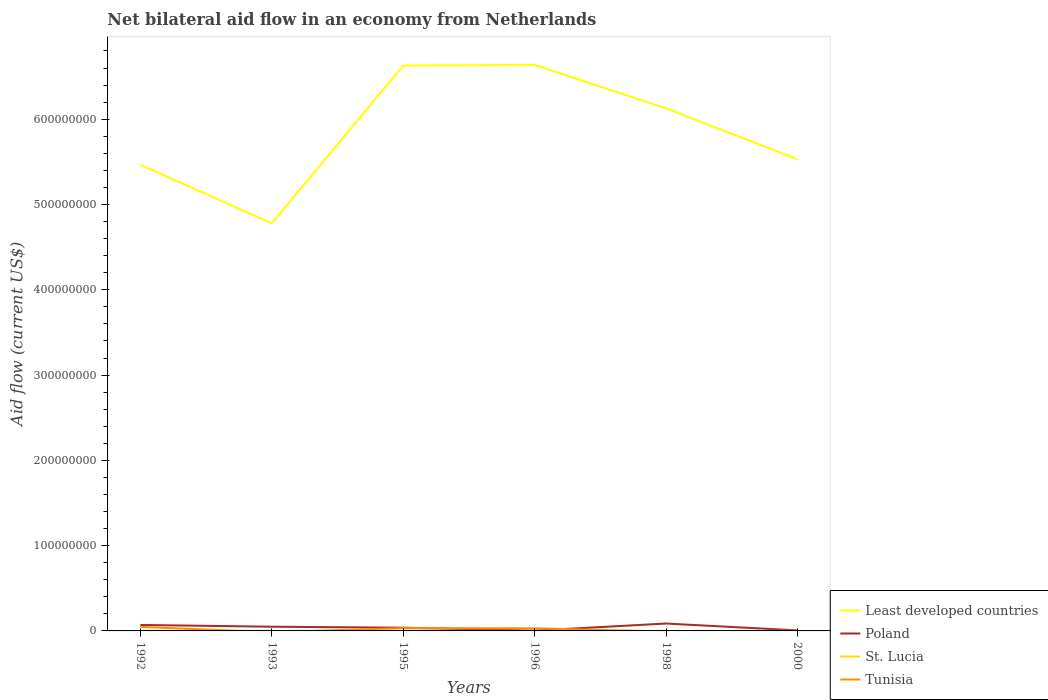How many different coloured lines are there?
Your answer should be very brief. 4. What is the total net bilateral aid flow in Tunisia in the graph?
Provide a short and direct response. 1.49e+06. What is the difference between the highest and the second highest net bilateral aid flow in Least developed countries?
Offer a very short reply. 1.86e+08. Is the net bilateral aid flow in Tunisia strictly greater than the net bilateral aid flow in Least developed countries over the years?
Your response must be concise. Yes. How many lines are there?
Offer a terse response. 4. How many years are there in the graph?
Provide a succinct answer. 6. What is the difference between two consecutive major ticks on the Y-axis?
Your answer should be compact. 1.00e+08. Does the graph contain any zero values?
Keep it short and to the point. Yes. How many legend labels are there?
Make the answer very short. 4. How are the legend labels stacked?
Your answer should be very brief. Vertical. What is the title of the graph?
Offer a very short reply. Net bilateral aid flow in an economy from Netherlands. Does "Madagascar" appear as one of the legend labels in the graph?
Your answer should be very brief. No. What is the label or title of the X-axis?
Provide a succinct answer. Years. What is the label or title of the Y-axis?
Make the answer very short. Aid flow (current US$). What is the Aid flow (current US$) of Least developed countries in 1992?
Keep it short and to the point. 5.47e+08. What is the Aid flow (current US$) of Poland in 1992?
Ensure brevity in your answer.  7.00e+06. What is the Aid flow (current US$) of St. Lucia in 1992?
Your answer should be compact. 1.80e+05. What is the Aid flow (current US$) of Tunisia in 1992?
Offer a terse response. 4.77e+06. What is the Aid flow (current US$) in Least developed countries in 1993?
Provide a succinct answer. 4.78e+08. What is the Aid flow (current US$) in Poland in 1993?
Provide a short and direct response. 4.94e+06. What is the Aid flow (current US$) in St. Lucia in 1993?
Your answer should be very brief. 1.30e+05. What is the Aid flow (current US$) of Least developed countries in 1995?
Keep it short and to the point. 6.63e+08. What is the Aid flow (current US$) in Poland in 1995?
Give a very brief answer. 3.75e+06. What is the Aid flow (current US$) in St. Lucia in 1995?
Keep it short and to the point. 1.90e+05. What is the Aid flow (current US$) in Tunisia in 1995?
Keep it short and to the point. 3.28e+06. What is the Aid flow (current US$) of Least developed countries in 1996?
Your answer should be very brief. 6.64e+08. What is the Aid flow (current US$) of Poland in 1996?
Ensure brevity in your answer.  3.60e+05. What is the Aid flow (current US$) in Tunisia in 1996?
Your response must be concise. 3.08e+06. What is the Aid flow (current US$) of Least developed countries in 1998?
Offer a terse response. 6.13e+08. What is the Aid flow (current US$) of Poland in 1998?
Ensure brevity in your answer.  8.66e+06. What is the Aid flow (current US$) in St. Lucia in 1998?
Keep it short and to the point. 1.10e+05. What is the Aid flow (current US$) in Tunisia in 1998?
Provide a short and direct response. 0. What is the Aid flow (current US$) in Least developed countries in 2000?
Your response must be concise. 5.53e+08. What is the Aid flow (current US$) of Poland in 2000?
Provide a short and direct response. 5.80e+05. What is the Aid flow (current US$) in St. Lucia in 2000?
Provide a succinct answer. 2.00e+04. Across all years, what is the maximum Aid flow (current US$) of Least developed countries?
Provide a short and direct response. 6.64e+08. Across all years, what is the maximum Aid flow (current US$) of Poland?
Your response must be concise. 8.66e+06. Across all years, what is the maximum Aid flow (current US$) in St. Lucia?
Your answer should be very brief. 1.90e+05. Across all years, what is the maximum Aid flow (current US$) of Tunisia?
Your answer should be very brief. 4.77e+06. Across all years, what is the minimum Aid flow (current US$) in Least developed countries?
Offer a very short reply. 4.78e+08. Across all years, what is the minimum Aid flow (current US$) of Poland?
Offer a terse response. 3.60e+05. Across all years, what is the minimum Aid flow (current US$) of St. Lucia?
Make the answer very short. 2.00e+04. Across all years, what is the minimum Aid flow (current US$) of Tunisia?
Offer a terse response. 0. What is the total Aid flow (current US$) in Least developed countries in the graph?
Ensure brevity in your answer.  3.52e+09. What is the total Aid flow (current US$) in Poland in the graph?
Give a very brief answer. 2.53e+07. What is the total Aid flow (current US$) in St. Lucia in the graph?
Your answer should be very brief. 7.20e+05. What is the total Aid flow (current US$) in Tunisia in the graph?
Offer a terse response. 1.11e+07. What is the difference between the Aid flow (current US$) of Least developed countries in 1992 and that in 1993?
Provide a succinct answer. 6.87e+07. What is the difference between the Aid flow (current US$) in Poland in 1992 and that in 1993?
Keep it short and to the point. 2.06e+06. What is the difference between the Aid flow (current US$) in Least developed countries in 1992 and that in 1995?
Ensure brevity in your answer.  -1.16e+08. What is the difference between the Aid flow (current US$) in Poland in 1992 and that in 1995?
Keep it short and to the point. 3.25e+06. What is the difference between the Aid flow (current US$) of Tunisia in 1992 and that in 1995?
Provide a succinct answer. 1.49e+06. What is the difference between the Aid flow (current US$) of Least developed countries in 1992 and that in 1996?
Offer a very short reply. -1.17e+08. What is the difference between the Aid flow (current US$) in Poland in 1992 and that in 1996?
Provide a short and direct response. 6.64e+06. What is the difference between the Aid flow (current US$) in Tunisia in 1992 and that in 1996?
Keep it short and to the point. 1.69e+06. What is the difference between the Aid flow (current US$) in Least developed countries in 1992 and that in 1998?
Offer a very short reply. -6.61e+07. What is the difference between the Aid flow (current US$) in Poland in 1992 and that in 1998?
Your answer should be compact. -1.66e+06. What is the difference between the Aid flow (current US$) of Least developed countries in 1992 and that in 2000?
Ensure brevity in your answer.  -6.55e+06. What is the difference between the Aid flow (current US$) of Poland in 1992 and that in 2000?
Keep it short and to the point. 6.42e+06. What is the difference between the Aid flow (current US$) in St. Lucia in 1992 and that in 2000?
Ensure brevity in your answer.  1.60e+05. What is the difference between the Aid flow (current US$) in Least developed countries in 1993 and that in 1995?
Provide a succinct answer. -1.85e+08. What is the difference between the Aid flow (current US$) of Poland in 1993 and that in 1995?
Keep it short and to the point. 1.19e+06. What is the difference between the Aid flow (current US$) in Least developed countries in 1993 and that in 1996?
Give a very brief answer. -1.86e+08. What is the difference between the Aid flow (current US$) in Poland in 1993 and that in 1996?
Your answer should be very brief. 4.58e+06. What is the difference between the Aid flow (current US$) in St. Lucia in 1993 and that in 1996?
Your response must be concise. 4.00e+04. What is the difference between the Aid flow (current US$) in Least developed countries in 1993 and that in 1998?
Provide a short and direct response. -1.35e+08. What is the difference between the Aid flow (current US$) of Poland in 1993 and that in 1998?
Provide a succinct answer. -3.72e+06. What is the difference between the Aid flow (current US$) of St. Lucia in 1993 and that in 1998?
Provide a succinct answer. 2.00e+04. What is the difference between the Aid flow (current US$) of Least developed countries in 1993 and that in 2000?
Offer a terse response. -7.52e+07. What is the difference between the Aid flow (current US$) in Poland in 1993 and that in 2000?
Offer a terse response. 4.36e+06. What is the difference between the Aid flow (current US$) in St. Lucia in 1993 and that in 2000?
Keep it short and to the point. 1.10e+05. What is the difference between the Aid flow (current US$) in Least developed countries in 1995 and that in 1996?
Provide a short and direct response. -7.40e+05. What is the difference between the Aid flow (current US$) in Poland in 1995 and that in 1996?
Give a very brief answer. 3.39e+06. What is the difference between the Aid flow (current US$) of Least developed countries in 1995 and that in 1998?
Ensure brevity in your answer.  5.02e+07. What is the difference between the Aid flow (current US$) in Poland in 1995 and that in 1998?
Ensure brevity in your answer.  -4.91e+06. What is the difference between the Aid flow (current US$) of Least developed countries in 1995 and that in 2000?
Provide a short and direct response. 1.10e+08. What is the difference between the Aid flow (current US$) of Poland in 1995 and that in 2000?
Your response must be concise. 3.17e+06. What is the difference between the Aid flow (current US$) in Least developed countries in 1996 and that in 1998?
Offer a very short reply. 5.10e+07. What is the difference between the Aid flow (current US$) of Poland in 1996 and that in 1998?
Offer a very short reply. -8.30e+06. What is the difference between the Aid flow (current US$) of St. Lucia in 1996 and that in 1998?
Offer a very short reply. -2.00e+04. What is the difference between the Aid flow (current US$) in Least developed countries in 1996 and that in 2000?
Ensure brevity in your answer.  1.10e+08. What is the difference between the Aid flow (current US$) of Poland in 1996 and that in 2000?
Ensure brevity in your answer.  -2.20e+05. What is the difference between the Aid flow (current US$) of St. Lucia in 1996 and that in 2000?
Make the answer very short. 7.00e+04. What is the difference between the Aid flow (current US$) in Least developed countries in 1998 and that in 2000?
Your answer should be compact. 5.95e+07. What is the difference between the Aid flow (current US$) in Poland in 1998 and that in 2000?
Make the answer very short. 8.08e+06. What is the difference between the Aid flow (current US$) in Least developed countries in 1992 and the Aid flow (current US$) in Poland in 1993?
Your response must be concise. 5.42e+08. What is the difference between the Aid flow (current US$) of Least developed countries in 1992 and the Aid flow (current US$) of St. Lucia in 1993?
Provide a succinct answer. 5.46e+08. What is the difference between the Aid flow (current US$) in Poland in 1992 and the Aid flow (current US$) in St. Lucia in 1993?
Your response must be concise. 6.87e+06. What is the difference between the Aid flow (current US$) of Least developed countries in 1992 and the Aid flow (current US$) of Poland in 1995?
Provide a short and direct response. 5.43e+08. What is the difference between the Aid flow (current US$) in Least developed countries in 1992 and the Aid flow (current US$) in St. Lucia in 1995?
Give a very brief answer. 5.46e+08. What is the difference between the Aid flow (current US$) in Least developed countries in 1992 and the Aid flow (current US$) in Tunisia in 1995?
Offer a terse response. 5.43e+08. What is the difference between the Aid flow (current US$) in Poland in 1992 and the Aid flow (current US$) in St. Lucia in 1995?
Give a very brief answer. 6.81e+06. What is the difference between the Aid flow (current US$) in Poland in 1992 and the Aid flow (current US$) in Tunisia in 1995?
Keep it short and to the point. 3.72e+06. What is the difference between the Aid flow (current US$) of St. Lucia in 1992 and the Aid flow (current US$) of Tunisia in 1995?
Offer a very short reply. -3.10e+06. What is the difference between the Aid flow (current US$) in Least developed countries in 1992 and the Aid flow (current US$) in Poland in 1996?
Provide a succinct answer. 5.46e+08. What is the difference between the Aid flow (current US$) of Least developed countries in 1992 and the Aid flow (current US$) of St. Lucia in 1996?
Offer a very short reply. 5.46e+08. What is the difference between the Aid flow (current US$) of Least developed countries in 1992 and the Aid flow (current US$) of Tunisia in 1996?
Give a very brief answer. 5.44e+08. What is the difference between the Aid flow (current US$) in Poland in 1992 and the Aid flow (current US$) in St. Lucia in 1996?
Give a very brief answer. 6.91e+06. What is the difference between the Aid flow (current US$) of Poland in 1992 and the Aid flow (current US$) of Tunisia in 1996?
Your answer should be very brief. 3.92e+06. What is the difference between the Aid flow (current US$) in St. Lucia in 1992 and the Aid flow (current US$) in Tunisia in 1996?
Offer a terse response. -2.90e+06. What is the difference between the Aid flow (current US$) of Least developed countries in 1992 and the Aid flow (current US$) of Poland in 1998?
Keep it short and to the point. 5.38e+08. What is the difference between the Aid flow (current US$) in Least developed countries in 1992 and the Aid flow (current US$) in St. Lucia in 1998?
Give a very brief answer. 5.46e+08. What is the difference between the Aid flow (current US$) of Poland in 1992 and the Aid flow (current US$) of St. Lucia in 1998?
Offer a very short reply. 6.89e+06. What is the difference between the Aid flow (current US$) in Least developed countries in 1992 and the Aid flow (current US$) in Poland in 2000?
Your answer should be compact. 5.46e+08. What is the difference between the Aid flow (current US$) in Least developed countries in 1992 and the Aid flow (current US$) in St. Lucia in 2000?
Offer a very short reply. 5.47e+08. What is the difference between the Aid flow (current US$) of Poland in 1992 and the Aid flow (current US$) of St. Lucia in 2000?
Offer a terse response. 6.98e+06. What is the difference between the Aid flow (current US$) in Least developed countries in 1993 and the Aid flow (current US$) in Poland in 1995?
Keep it short and to the point. 4.74e+08. What is the difference between the Aid flow (current US$) of Least developed countries in 1993 and the Aid flow (current US$) of St. Lucia in 1995?
Your answer should be compact. 4.78e+08. What is the difference between the Aid flow (current US$) of Least developed countries in 1993 and the Aid flow (current US$) of Tunisia in 1995?
Ensure brevity in your answer.  4.75e+08. What is the difference between the Aid flow (current US$) in Poland in 1993 and the Aid flow (current US$) in St. Lucia in 1995?
Keep it short and to the point. 4.75e+06. What is the difference between the Aid flow (current US$) of Poland in 1993 and the Aid flow (current US$) of Tunisia in 1995?
Offer a very short reply. 1.66e+06. What is the difference between the Aid flow (current US$) of St. Lucia in 1993 and the Aid flow (current US$) of Tunisia in 1995?
Your response must be concise. -3.15e+06. What is the difference between the Aid flow (current US$) in Least developed countries in 1993 and the Aid flow (current US$) in Poland in 1996?
Your answer should be compact. 4.78e+08. What is the difference between the Aid flow (current US$) in Least developed countries in 1993 and the Aid flow (current US$) in St. Lucia in 1996?
Provide a succinct answer. 4.78e+08. What is the difference between the Aid flow (current US$) in Least developed countries in 1993 and the Aid flow (current US$) in Tunisia in 1996?
Provide a succinct answer. 4.75e+08. What is the difference between the Aid flow (current US$) in Poland in 1993 and the Aid flow (current US$) in St. Lucia in 1996?
Provide a succinct answer. 4.85e+06. What is the difference between the Aid flow (current US$) in Poland in 1993 and the Aid flow (current US$) in Tunisia in 1996?
Ensure brevity in your answer.  1.86e+06. What is the difference between the Aid flow (current US$) of St. Lucia in 1993 and the Aid flow (current US$) of Tunisia in 1996?
Give a very brief answer. -2.95e+06. What is the difference between the Aid flow (current US$) of Least developed countries in 1993 and the Aid flow (current US$) of Poland in 1998?
Your answer should be very brief. 4.69e+08. What is the difference between the Aid flow (current US$) in Least developed countries in 1993 and the Aid flow (current US$) in St. Lucia in 1998?
Your answer should be compact. 4.78e+08. What is the difference between the Aid flow (current US$) in Poland in 1993 and the Aid flow (current US$) in St. Lucia in 1998?
Ensure brevity in your answer.  4.83e+06. What is the difference between the Aid flow (current US$) in Least developed countries in 1993 and the Aid flow (current US$) in Poland in 2000?
Offer a terse response. 4.77e+08. What is the difference between the Aid flow (current US$) of Least developed countries in 1993 and the Aid flow (current US$) of St. Lucia in 2000?
Give a very brief answer. 4.78e+08. What is the difference between the Aid flow (current US$) of Poland in 1993 and the Aid flow (current US$) of St. Lucia in 2000?
Make the answer very short. 4.92e+06. What is the difference between the Aid flow (current US$) of Least developed countries in 1995 and the Aid flow (current US$) of Poland in 1996?
Offer a terse response. 6.63e+08. What is the difference between the Aid flow (current US$) in Least developed countries in 1995 and the Aid flow (current US$) in St. Lucia in 1996?
Your answer should be very brief. 6.63e+08. What is the difference between the Aid flow (current US$) in Least developed countries in 1995 and the Aid flow (current US$) in Tunisia in 1996?
Offer a very short reply. 6.60e+08. What is the difference between the Aid flow (current US$) of Poland in 1995 and the Aid flow (current US$) of St. Lucia in 1996?
Provide a short and direct response. 3.66e+06. What is the difference between the Aid flow (current US$) of Poland in 1995 and the Aid flow (current US$) of Tunisia in 1996?
Provide a short and direct response. 6.70e+05. What is the difference between the Aid flow (current US$) of St. Lucia in 1995 and the Aid flow (current US$) of Tunisia in 1996?
Your answer should be compact. -2.89e+06. What is the difference between the Aid flow (current US$) in Least developed countries in 1995 and the Aid flow (current US$) in Poland in 1998?
Make the answer very short. 6.54e+08. What is the difference between the Aid flow (current US$) in Least developed countries in 1995 and the Aid flow (current US$) in St. Lucia in 1998?
Give a very brief answer. 6.63e+08. What is the difference between the Aid flow (current US$) in Poland in 1995 and the Aid flow (current US$) in St. Lucia in 1998?
Provide a short and direct response. 3.64e+06. What is the difference between the Aid flow (current US$) of Least developed countries in 1995 and the Aid flow (current US$) of Poland in 2000?
Ensure brevity in your answer.  6.62e+08. What is the difference between the Aid flow (current US$) in Least developed countries in 1995 and the Aid flow (current US$) in St. Lucia in 2000?
Ensure brevity in your answer.  6.63e+08. What is the difference between the Aid flow (current US$) of Poland in 1995 and the Aid flow (current US$) of St. Lucia in 2000?
Your answer should be very brief. 3.73e+06. What is the difference between the Aid flow (current US$) in Least developed countries in 1996 and the Aid flow (current US$) in Poland in 1998?
Offer a terse response. 6.55e+08. What is the difference between the Aid flow (current US$) in Least developed countries in 1996 and the Aid flow (current US$) in St. Lucia in 1998?
Your answer should be very brief. 6.64e+08. What is the difference between the Aid flow (current US$) in Poland in 1996 and the Aid flow (current US$) in St. Lucia in 1998?
Ensure brevity in your answer.  2.50e+05. What is the difference between the Aid flow (current US$) in Least developed countries in 1996 and the Aid flow (current US$) in Poland in 2000?
Your response must be concise. 6.63e+08. What is the difference between the Aid flow (current US$) of Least developed countries in 1996 and the Aid flow (current US$) of St. Lucia in 2000?
Provide a short and direct response. 6.64e+08. What is the difference between the Aid flow (current US$) in Least developed countries in 1998 and the Aid flow (current US$) in Poland in 2000?
Provide a succinct answer. 6.12e+08. What is the difference between the Aid flow (current US$) in Least developed countries in 1998 and the Aid flow (current US$) in St. Lucia in 2000?
Your answer should be compact. 6.13e+08. What is the difference between the Aid flow (current US$) of Poland in 1998 and the Aid flow (current US$) of St. Lucia in 2000?
Offer a terse response. 8.64e+06. What is the average Aid flow (current US$) in Least developed countries per year?
Ensure brevity in your answer.  5.86e+08. What is the average Aid flow (current US$) in Poland per year?
Give a very brief answer. 4.22e+06. What is the average Aid flow (current US$) of St. Lucia per year?
Provide a short and direct response. 1.20e+05. What is the average Aid flow (current US$) in Tunisia per year?
Give a very brief answer. 1.86e+06. In the year 1992, what is the difference between the Aid flow (current US$) in Least developed countries and Aid flow (current US$) in Poland?
Give a very brief answer. 5.40e+08. In the year 1992, what is the difference between the Aid flow (current US$) of Least developed countries and Aid flow (current US$) of St. Lucia?
Ensure brevity in your answer.  5.46e+08. In the year 1992, what is the difference between the Aid flow (current US$) in Least developed countries and Aid flow (current US$) in Tunisia?
Offer a terse response. 5.42e+08. In the year 1992, what is the difference between the Aid flow (current US$) of Poland and Aid flow (current US$) of St. Lucia?
Your answer should be compact. 6.82e+06. In the year 1992, what is the difference between the Aid flow (current US$) in Poland and Aid flow (current US$) in Tunisia?
Offer a very short reply. 2.23e+06. In the year 1992, what is the difference between the Aid flow (current US$) of St. Lucia and Aid flow (current US$) of Tunisia?
Offer a very short reply. -4.59e+06. In the year 1993, what is the difference between the Aid flow (current US$) of Least developed countries and Aid flow (current US$) of Poland?
Your answer should be compact. 4.73e+08. In the year 1993, what is the difference between the Aid flow (current US$) of Least developed countries and Aid flow (current US$) of St. Lucia?
Offer a very short reply. 4.78e+08. In the year 1993, what is the difference between the Aid flow (current US$) of Poland and Aid flow (current US$) of St. Lucia?
Your answer should be very brief. 4.81e+06. In the year 1995, what is the difference between the Aid flow (current US$) in Least developed countries and Aid flow (current US$) in Poland?
Give a very brief answer. 6.59e+08. In the year 1995, what is the difference between the Aid flow (current US$) of Least developed countries and Aid flow (current US$) of St. Lucia?
Ensure brevity in your answer.  6.63e+08. In the year 1995, what is the difference between the Aid flow (current US$) of Least developed countries and Aid flow (current US$) of Tunisia?
Provide a succinct answer. 6.60e+08. In the year 1995, what is the difference between the Aid flow (current US$) of Poland and Aid flow (current US$) of St. Lucia?
Provide a succinct answer. 3.56e+06. In the year 1995, what is the difference between the Aid flow (current US$) of Poland and Aid flow (current US$) of Tunisia?
Make the answer very short. 4.70e+05. In the year 1995, what is the difference between the Aid flow (current US$) in St. Lucia and Aid flow (current US$) in Tunisia?
Provide a succinct answer. -3.09e+06. In the year 1996, what is the difference between the Aid flow (current US$) of Least developed countries and Aid flow (current US$) of Poland?
Give a very brief answer. 6.63e+08. In the year 1996, what is the difference between the Aid flow (current US$) of Least developed countries and Aid flow (current US$) of St. Lucia?
Ensure brevity in your answer.  6.64e+08. In the year 1996, what is the difference between the Aid flow (current US$) of Least developed countries and Aid flow (current US$) of Tunisia?
Your response must be concise. 6.61e+08. In the year 1996, what is the difference between the Aid flow (current US$) in Poland and Aid flow (current US$) in Tunisia?
Keep it short and to the point. -2.72e+06. In the year 1996, what is the difference between the Aid flow (current US$) of St. Lucia and Aid flow (current US$) of Tunisia?
Offer a terse response. -2.99e+06. In the year 1998, what is the difference between the Aid flow (current US$) of Least developed countries and Aid flow (current US$) of Poland?
Your answer should be compact. 6.04e+08. In the year 1998, what is the difference between the Aid flow (current US$) in Least developed countries and Aid flow (current US$) in St. Lucia?
Offer a terse response. 6.13e+08. In the year 1998, what is the difference between the Aid flow (current US$) of Poland and Aid flow (current US$) of St. Lucia?
Ensure brevity in your answer.  8.55e+06. In the year 2000, what is the difference between the Aid flow (current US$) in Least developed countries and Aid flow (current US$) in Poland?
Provide a short and direct response. 5.53e+08. In the year 2000, what is the difference between the Aid flow (current US$) in Least developed countries and Aid flow (current US$) in St. Lucia?
Make the answer very short. 5.53e+08. In the year 2000, what is the difference between the Aid flow (current US$) of Poland and Aid flow (current US$) of St. Lucia?
Your answer should be compact. 5.60e+05. What is the ratio of the Aid flow (current US$) in Least developed countries in 1992 to that in 1993?
Offer a very short reply. 1.14. What is the ratio of the Aid flow (current US$) in Poland in 1992 to that in 1993?
Your answer should be very brief. 1.42. What is the ratio of the Aid flow (current US$) of St. Lucia in 1992 to that in 1993?
Your answer should be very brief. 1.38. What is the ratio of the Aid flow (current US$) in Least developed countries in 1992 to that in 1995?
Provide a short and direct response. 0.82. What is the ratio of the Aid flow (current US$) of Poland in 1992 to that in 1995?
Keep it short and to the point. 1.87. What is the ratio of the Aid flow (current US$) in St. Lucia in 1992 to that in 1995?
Your response must be concise. 0.95. What is the ratio of the Aid flow (current US$) of Tunisia in 1992 to that in 1995?
Your answer should be compact. 1.45. What is the ratio of the Aid flow (current US$) of Least developed countries in 1992 to that in 1996?
Provide a succinct answer. 0.82. What is the ratio of the Aid flow (current US$) of Poland in 1992 to that in 1996?
Your answer should be compact. 19.44. What is the ratio of the Aid flow (current US$) of St. Lucia in 1992 to that in 1996?
Make the answer very short. 2. What is the ratio of the Aid flow (current US$) of Tunisia in 1992 to that in 1996?
Provide a succinct answer. 1.55. What is the ratio of the Aid flow (current US$) in Least developed countries in 1992 to that in 1998?
Give a very brief answer. 0.89. What is the ratio of the Aid flow (current US$) in Poland in 1992 to that in 1998?
Give a very brief answer. 0.81. What is the ratio of the Aid flow (current US$) of St. Lucia in 1992 to that in 1998?
Provide a succinct answer. 1.64. What is the ratio of the Aid flow (current US$) of Poland in 1992 to that in 2000?
Your answer should be compact. 12.07. What is the ratio of the Aid flow (current US$) of Least developed countries in 1993 to that in 1995?
Offer a terse response. 0.72. What is the ratio of the Aid flow (current US$) in Poland in 1993 to that in 1995?
Provide a short and direct response. 1.32. What is the ratio of the Aid flow (current US$) of St. Lucia in 1993 to that in 1995?
Give a very brief answer. 0.68. What is the ratio of the Aid flow (current US$) of Least developed countries in 1993 to that in 1996?
Provide a short and direct response. 0.72. What is the ratio of the Aid flow (current US$) of Poland in 1993 to that in 1996?
Your answer should be compact. 13.72. What is the ratio of the Aid flow (current US$) in St. Lucia in 1993 to that in 1996?
Your answer should be very brief. 1.44. What is the ratio of the Aid flow (current US$) in Least developed countries in 1993 to that in 1998?
Make the answer very short. 0.78. What is the ratio of the Aid flow (current US$) of Poland in 1993 to that in 1998?
Offer a terse response. 0.57. What is the ratio of the Aid flow (current US$) of St. Lucia in 1993 to that in 1998?
Your response must be concise. 1.18. What is the ratio of the Aid flow (current US$) of Least developed countries in 1993 to that in 2000?
Provide a succinct answer. 0.86. What is the ratio of the Aid flow (current US$) of Poland in 1993 to that in 2000?
Ensure brevity in your answer.  8.52. What is the ratio of the Aid flow (current US$) of St. Lucia in 1993 to that in 2000?
Provide a short and direct response. 6.5. What is the ratio of the Aid flow (current US$) in Poland in 1995 to that in 1996?
Keep it short and to the point. 10.42. What is the ratio of the Aid flow (current US$) of St. Lucia in 1995 to that in 1996?
Your response must be concise. 2.11. What is the ratio of the Aid flow (current US$) of Tunisia in 1995 to that in 1996?
Provide a succinct answer. 1.06. What is the ratio of the Aid flow (current US$) in Least developed countries in 1995 to that in 1998?
Your response must be concise. 1.08. What is the ratio of the Aid flow (current US$) in Poland in 1995 to that in 1998?
Offer a very short reply. 0.43. What is the ratio of the Aid flow (current US$) of St. Lucia in 1995 to that in 1998?
Provide a short and direct response. 1.73. What is the ratio of the Aid flow (current US$) of Least developed countries in 1995 to that in 2000?
Offer a very short reply. 1.2. What is the ratio of the Aid flow (current US$) of Poland in 1995 to that in 2000?
Offer a very short reply. 6.47. What is the ratio of the Aid flow (current US$) of St. Lucia in 1995 to that in 2000?
Provide a succinct answer. 9.5. What is the ratio of the Aid flow (current US$) in Least developed countries in 1996 to that in 1998?
Make the answer very short. 1.08. What is the ratio of the Aid flow (current US$) in Poland in 1996 to that in 1998?
Give a very brief answer. 0.04. What is the ratio of the Aid flow (current US$) of St. Lucia in 1996 to that in 1998?
Offer a terse response. 0.82. What is the ratio of the Aid flow (current US$) of Least developed countries in 1996 to that in 2000?
Offer a terse response. 1.2. What is the ratio of the Aid flow (current US$) of Poland in 1996 to that in 2000?
Ensure brevity in your answer.  0.62. What is the ratio of the Aid flow (current US$) of Least developed countries in 1998 to that in 2000?
Keep it short and to the point. 1.11. What is the ratio of the Aid flow (current US$) of Poland in 1998 to that in 2000?
Offer a terse response. 14.93. What is the difference between the highest and the second highest Aid flow (current US$) of Least developed countries?
Your answer should be compact. 7.40e+05. What is the difference between the highest and the second highest Aid flow (current US$) of Poland?
Keep it short and to the point. 1.66e+06. What is the difference between the highest and the second highest Aid flow (current US$) of St. Lucia?
Give a very brief answer. 10000. What is the difference between the highest and the second highest Aid flow (current US$) of Tunisia?
Give a very brief answer. 1.49e+06. What is the difference between the highest and the lowest Aid flow (current US$) of Least developed countries?
Your response must be concise. 1.86e+08. What is the difference between the highest and the lowest Aid flow (current US$) in Poland?
Your response must be concise. 8.30e+06. What is the difference between the highest and the lowest Aid flow (current US$) in St. Lucia?
Keep it short and to the point. 1.70e+05. What is the difference between the highest and the lowest Aid flow (current US$) of Tunisia?
Your answer should be compact. 4.77e+06. 